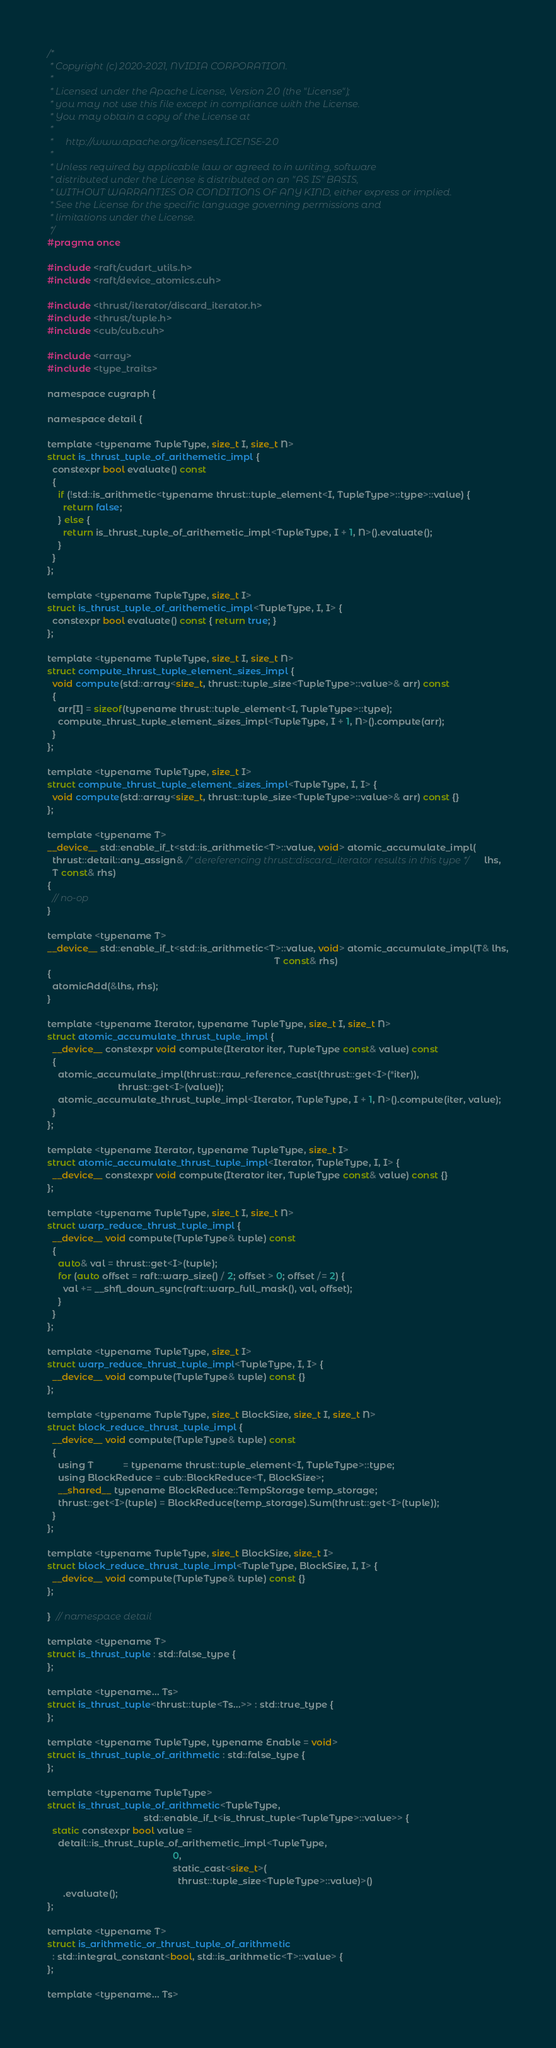Convert code to text. <code><loc_0><loc_0><loc_500><loc_500><_Cuda_>/*
 * Copyright (c) 2020-2021, NVIDIA CORPORATION.
 *
 * Licensed under the Apache License, Version 2.0 (the "License");
 * you may not use this file except in compliance with the License.
 * You may obtain a copy of the License at
 *
 *     http://www.apache.org/licenses/LICENSE-2.0
 *
 * Unless required by applicable law or agreed to in writing, software
 * distributed under the License is distributed on an "AS IS" BASIS,
 * WITHOUT WARRANTIES OR CONDITIONS OF ANY KIND, either express or implied.
 * See the License for the specific language governing permissions and
 * limitations under the License.
 */
#pragma once

#include <raft/cudart_utils.h>
#include <raft/device_atomics.cuh>

#include <thrust/iterator/discard_iterator.h>
#include <thrust/tuple.h>
#include <cub/cub.cuh>

#include <array>
#include <type_traits>

namespace cugraph {

namespace detail {

template <typename TupleType, size_t I, size_t N>
struct is_thrust_tuple_of_arithemetic_impl {
  constexpr bool evaluate() const
  {
    if (!std::is_arithmetic<typename thrust::tuple_element<I, TupleType>::type>::value) {
      return false;
    } else {
      return is_thrust_tuple_of_arithemetic_impl<TupleType, I + 1, N>().evaluate();
    }
  }
};

template <typename TupleType, size_t I>
struct is_thrust_tuple_of_arithemetic_impl<TupleType, I, I> {
  constexpr bool evaluate() const { return true; }
};

template <typename TupleType, size_t I, size_t N>
struct compute_thrust_tuple_element_sizes_impl {
  void compute(std::array<size_t, thrust::tuple_size<TupleType>::value>& arr) const
  {
    arr[I] = sizeof(typename thrust::tuple_element<I, TupleType>::type);
    compute_thrust_tuple_element_sizes_impl<TupleType, I + 1, N>().compute(arr);
  }
};

template <typename TupleType, size_t I>
struct compute_thrust_tuple_element_sizes_impl<TupleType, I, I> {
  void compute(std::array<size_t, thrust::tuple_size<TupleType>::value>& arr) const {}
};

template <typename T>
__device__ std::enable_if_t<std::is_arithmetic<T>::value, void> atomic_accumulate_impl(
  thrust::detail::any_assign& /* dereferencing thrust::discard_iterator results in this type */ lhs,
  T const& rhs)
{
  // no-op
}

template <typename T>
__device__ std::enable_if_t<std::is_arithmetic<T>::value, void> atomic_accumulate_impl(T& lhs,
                                                                                       T const& rhs)
{
  atomicAdd(&lhs, rhs);
}

template <typename Iterator, typename TupleType, size_t I, size_t N>
struct atomic_accumulate_thrust_tuple_impl {
  __device__ constexpr void compute(Iterator iter, TupleType const& value) const
  {
    atomic_accumulate_impl(thrust::raw_reference_cast(thrust::get<I>(*iter)),
                           thrust::get<I>(value));
    atomic_accumulate_thrust_tuple_impl<Iterator, TupleType, I + 1, N>().compute(iter, value);
  }
};

template <typename Iterator, typename TupleType, size_t I>
struct atomic_accumulate_thrust_tuple_impl<Iterator, TupleType, I, I> {
  __device__ constexpr void compute(Iterator iter, TupleType const& value) const {}
};

template <typename TupleType, size_t I, size_t N>
struct warp_reduce_thrust_tuple_impl {
  __device__ void compute(TupleType& tuple) const
  {
    auto& val = thrust::get<I>(tuple);
    for (auto offset = raft::warp_size() / 2; offset > 0; offset /= 2) {
      val += __shfl_down_sync(raft::warp_full_mask(), val, offset);
    }
  }
};

template <typename TupleType, size_t I>
struct warp_reduce_thrust_tuple_impl<TupleType, I, I> {
  __device__ void compute(TupleType& tuple) const {}
};

template <typename TupleType, size_t BlockSize, size_t I, size_t N>
struct block_reduce_thrust_tuple_impl {
  __device__ void compute(TupleType& tuple) const
  {
    using T           = typename thrust::tuple_element<I, TupleType>::type;
    using BlockReduce = cub::BlockReduce<T, BlockSize>;
    __shared__ typename BlockReduce::TempStorage temp_storage;
    thrust::get<I>(tuple) = BlockReduce(temp_storage).Sum(thrust::get<I>(tuple));
  }
};

template <typename TupleType, size_t BlockSize, size_t I>
struct block_reduce_thrust_tuple_impl<TupleType, BlockSize, I, I> {
  __device__ void compute(TupleType& tuple) const {}
};

}  // namespace detail

template <typename T>
struct is_thrust_tuple : std::false_type {
};

template <typename... Ts>
struct is_thrust_tuple<thrust::tuple<Ts...>> : std::true_type {
};

template <typename TupleType, typename Enable = void>
struct is_thrust_tuple_of_arithmetic : std::false_type {
};

template <typename TupleType>
struct is_thrust_tuple_of_arithmetic<TupleType,
                                     std::enable_if_t<is_thrust_tuple<TupleType>::value>> {
  static constexpr bool value =
    detail::is_thrust_tuple_of_arithemetic_impl<TupleType,
                                                0,
                                                static_cast<size_t>(
                                                  thrust::tuple_size<TupleType>::value)>()
      .evaluate();
};

template <typename T>
struct is_arithmetic_or_thrust_tuple_of_arithmetic
  : std::integral_constant<bool, std::is_arithmetic<T>::value> {
};

template <typename... Ts></code> 